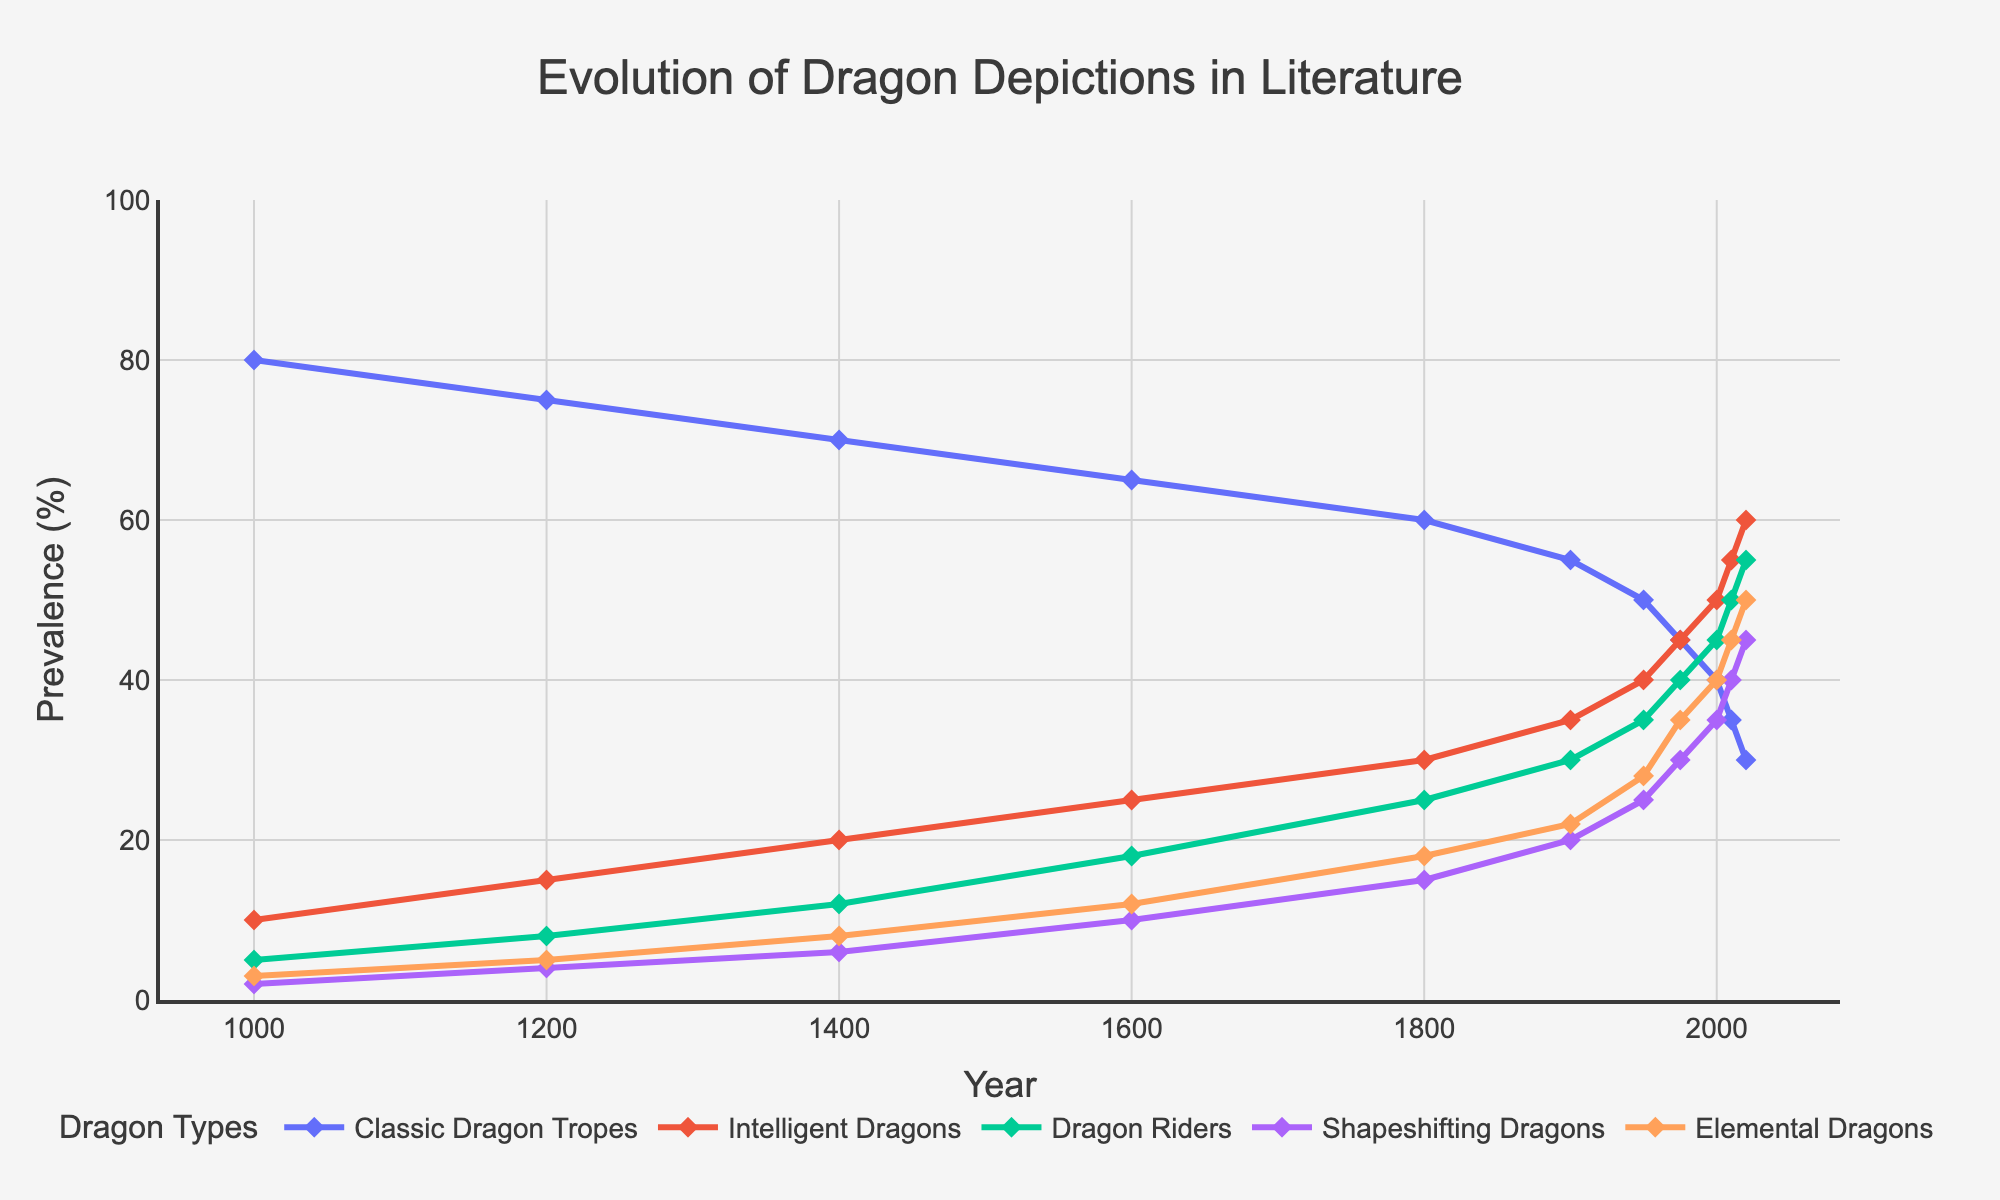Which dragon type reaches the highest prevalence in 2020? The figure shows that Elemental Dragons have the highest prevalence in 2020, as their line peaks at 50%.
Answer: Elemental Dragons How did the prevalence of Classic Dragon Tropes change from the year 1000 to 2020? Looking at the line for Classic Dragon Tropes, it starts at 80% in the year 1000 and decreases to 30% by 2020. The change in prevalence is 80% - 30% = 50% decrease.
Answer: Decreased by 50% Which dragon type had a steeper increase in prevalence from 1400 to 1600, Intelligent Dragons or Shapeshifting Dragons? Intelligent Dragons increased from 20% to 25%, which is a 5% increase. Shapeshifting Dragons increased from 6% to 10%, which is a 4% increase. Thus, Intelligent Dragons had a steeper increase.
Answer: Intelligent Dragons What is the average prevalence of Dragon Riders across all the years provided? Sum of prevalence values for Dragon Riders: 5 + 8 + 12 + 18 + 25 + 30 + 35 + 40 + 45 + 50 + 55 = 323. Number of years = 11. Average = 323 / 11 ≈ 29.36.
Answer: 29.36 Between which two consecutive years did Shapeshifting Dragons experience the highest increase in prevalence? Observing the Shapeshifting Dragons line, the largest increase is between 1950 and 1975, moving from 25% to 30%, which is a 5% increase.
Answer: 1950 and 1975 Which dragon types were more prevalent than Classic Dragon Tropes in 2020? In 2020, the prevalence values are: Classic Dragon Tropes (30%), Intelligent Dragons (60%), Dragon Riders (55%), Shapeshifting Dragons (45%), Elemental Dragons (50%). Intelligent Dragons, Dragon Riders, Shapeshifting Dragons, and Elemental Dragons are all more prevalent.
Answer: Intelligent Dragons, Dragon Riders, Shapeshifting Dragons, Elemental Dragons Was the prevalence of Intelligent Dragons always increasing from 1000 to 2020? The line for Intelligent Dragons consistently rises from 10% in 1000 to 60% in 2020, indicating a continual increase.
Answer: Yes What is the total increase in prevalence for Elemental Dragons from 1000 to 2020? Elemental Dragons go from a prevalence of 3% in 1000 to 50% in 2020. The total increase is 50% - 3% = 47%.
Answer: 47% From 1950 to 2010, which dragon type had the highest overall increase in prevalence? Comparing the increases from 1950 to 2010: 
- Classic Dragon Tropes: 50% to 35% (decrease of -15%)
- Intelligent Dragons: 40% to 55% (increase of 15%)
- Dragon Riders: 35% to 50% (increase of 15%)
- Shapeshifting Dragons: 25% to 40% (increase of 15%)
- Elemental Dragons: 28% to 45% (increase of 17%)
 
Thus, Elemental Dragons had the highest overall increase of 17%.
Answer: Elemental Dragons Considering the lines’ slopes, which dragon type demonstrates a notable incline in prevalence around 1900? Around 1900, Intelligent Dragons show a notable incline as their line steeply increases around this period from 30% to 35%, indicating a sharp rise in prevalence.
Answer: Intelligent Dragons 